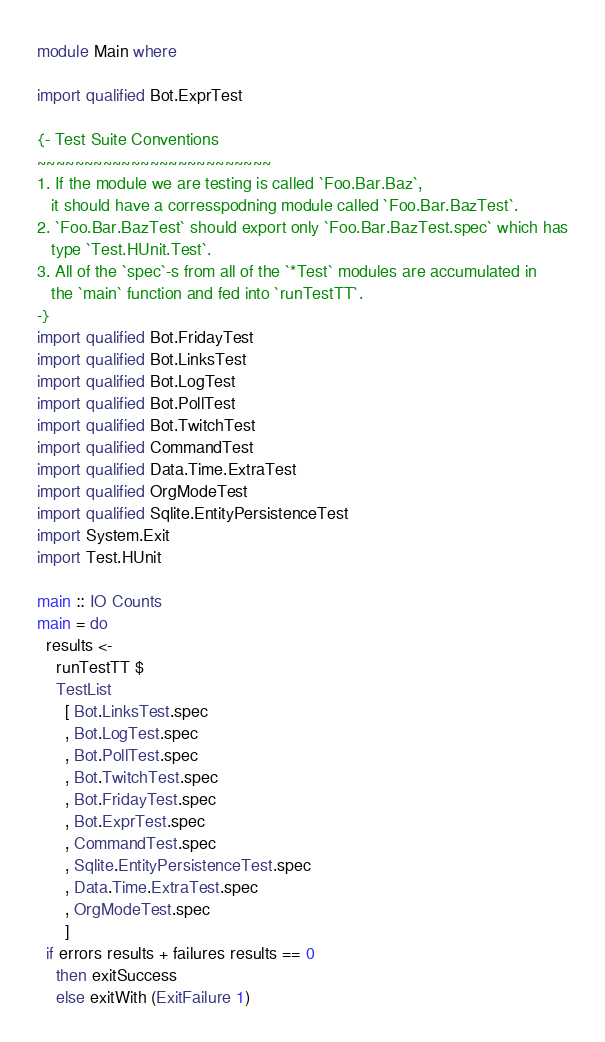<code> <loc_0><loc_0><loc_500><loc_500><_Haskell_>module Main where

import qualified Bot.ExprTest

{- Test Suite Conventions
~~~~~~~~~~~~~~~~~~~~~~~~~
1. If the module we are testing is called `Foo.Bar.Baz`,
   it should have a corresspodning module called `Foo.Bar.BazTest`.
2. `Foo.Bar.BazTest` should export only `Foo.Bar.BazTest.spec` which has
   type `Test.HUnit.Test`.
3. All of the `spec`-s from all of the `*Test` modules are accumulated in
   the `main` function and fed into `runTestTT`.
-}
import qualified Bot.FridayTest
import qualified Bot.LinksTest
import qualified Bot.LogTest
import qualified Bot.PollTest
import qualified Bot.TwitchTest
import qualified CommandTest
import qualified Data.Time.ExtraTest
import qualified OrgModeTest
import qualified Sqlite.EntityPersistenceTest
import System.Exit
import Test.HUnit

main :: IO Counts
main = do
  results <-
    runTestTT $
    TestList
      [ Bot.LinksTest.spec
      , Bot.LogTest.spec
      , Bot.PollTest.spec
      , Bot.TwitchTest.spec
      , Bot.FridayTest.spec
      , Bot.ExprTest.spec
      , CommandTest.spec
      , Sqlite.EntityPersistenceTest.spec
      , Data.Time.ExtraTest.spec
      , OrgModeTest.spec
      ]
  if errors results + failures results == 0
    then exitSuccess
    else exitWith (ExitFailure 1)
</code> 